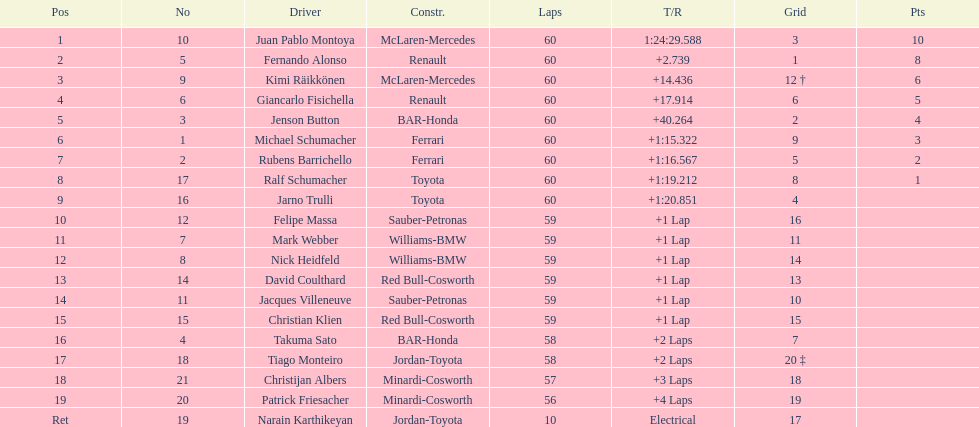Which driver came after giancarlo fisichella? Jenson Button. 